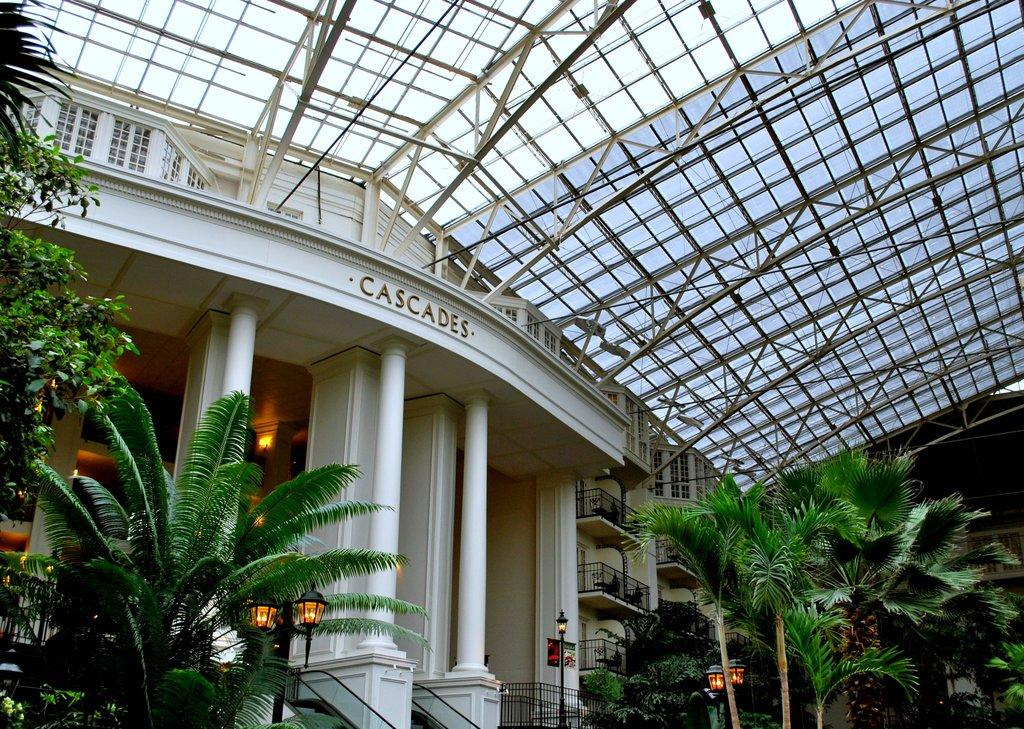What type of structures can be seen in the image? There are buildings in the image. Can you describe a specific architectural feature of the buildings? There are pillars in the image. What is located in front of the buildings? There are trees in front of the buildings. What type of lighting is present in the image? There are lamps in the image. What is at the top of the buildings? There is a roof at the top of the buildings. What type of card is being used to connect the buildings in the image? There is no card or connection between the buildings in the image; they are separate structures. 